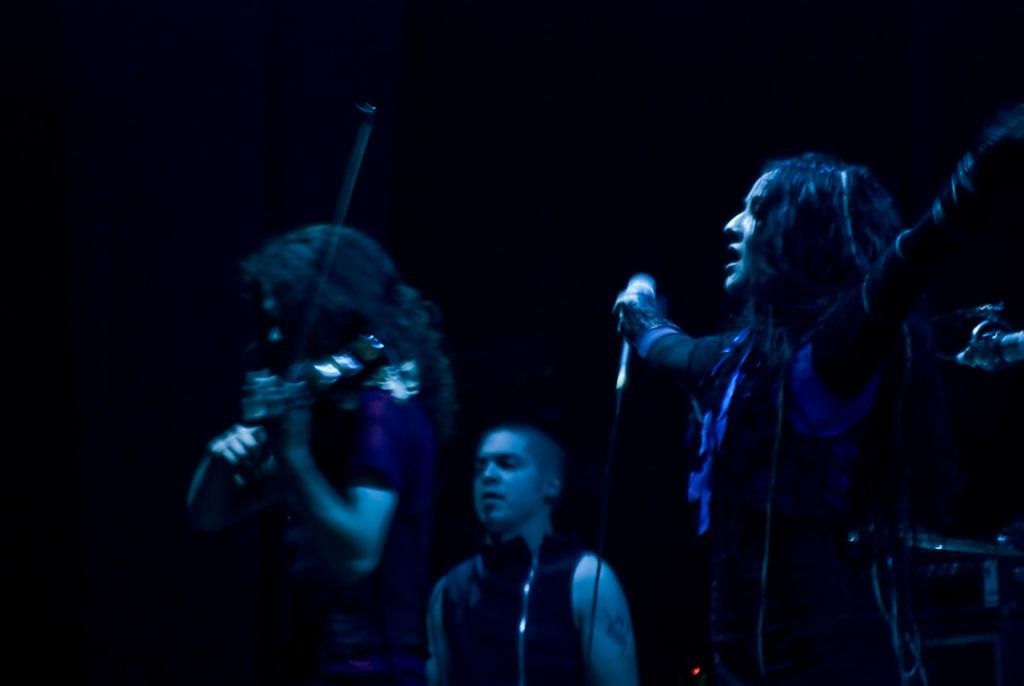What are the people in the image doing? The people in the image are playing musical instruments. Can you describe the person holding an object in their hand? One person is holding a mic in their hand. What is the color of the background in the image? The background of the image is dark. How do the waves affect the musical performance in the image? There are no waves present in the image, so they cannot affect the musical performance. 